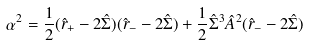Convert formula to latex. <formula><loc_0><loc_0><loc_500><loc_500>\alpha ^ { 2 } = \frac { 1 } { 2 } ( \hat { r } _ { + } - 2 \hat { \Sigma } ) ( \hat { r } _ { - } - 2 \hat { \Sigma } ) + \frac { 1 } { 2 } \hat { \Sigma } ^ { 3 } \hat { A } ^ { 2 } ( \hat { r } _ { - } - 2 \hat { \Sigma } )</formula> 